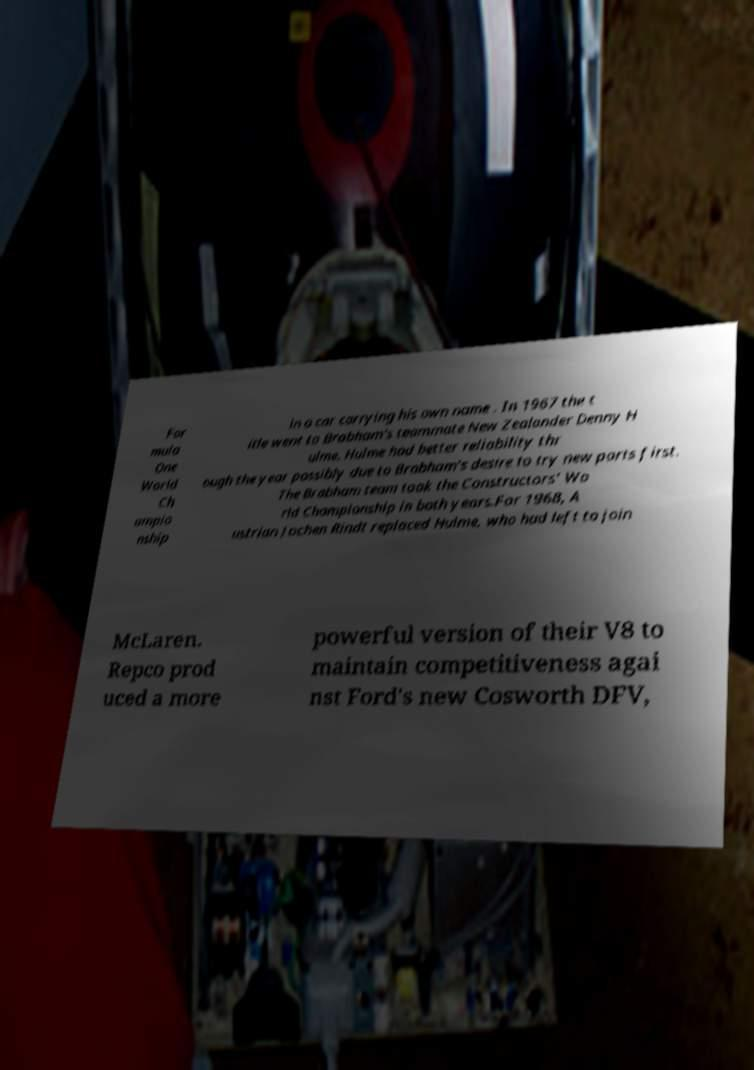There's text embedded in this image that I need extracted. Can you transcribe it verbatim? For mula One World Ch ampio nship in a car carrying his own name . In 1967 the t itle went to Brabham's teammate New Zealander Denny H ulme. Hulme had better reliability thr ough the year possibly due to Brabham's desire to try new parts first. The Brabham team took the Constructors' Wo rld Championship in both years.For 1968, A ustrian Jochen Rindt replaced Hulme, who had left to join McLaren. Repco prod uced a more powerful version of their V8 to maintain competitiveness agai nst Ford's new Cosworth DFV, 